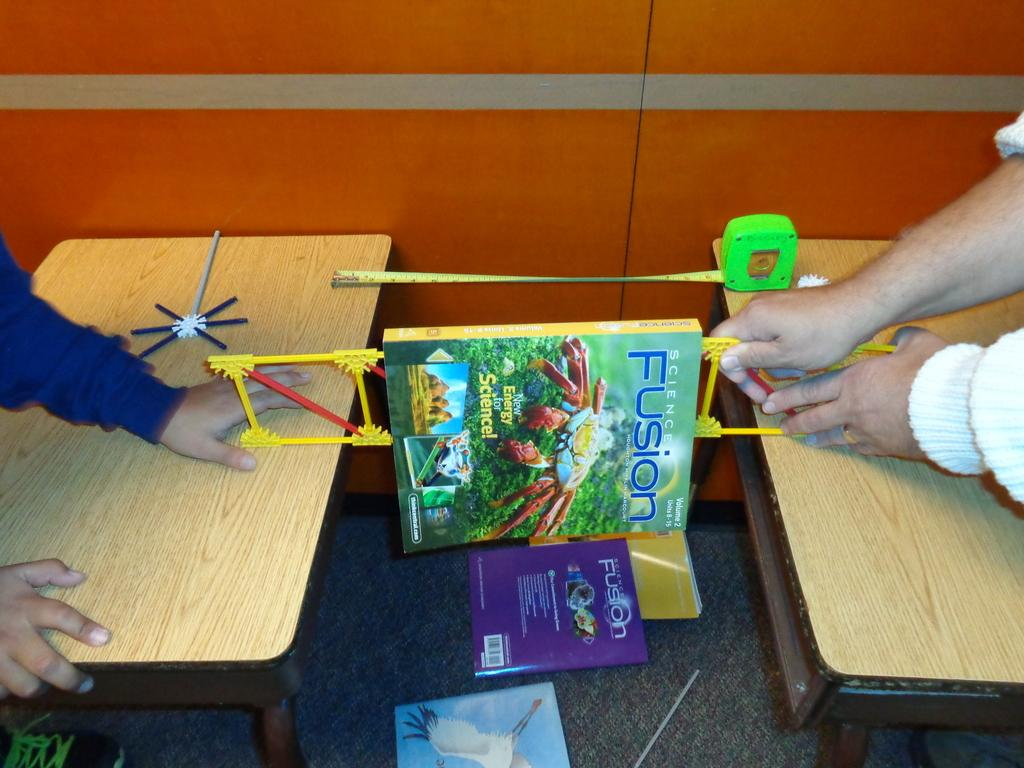<image>
Give a short and clear explanation of the subsequent image. People holding palstic frame with book" Fusion" hanging over it. 